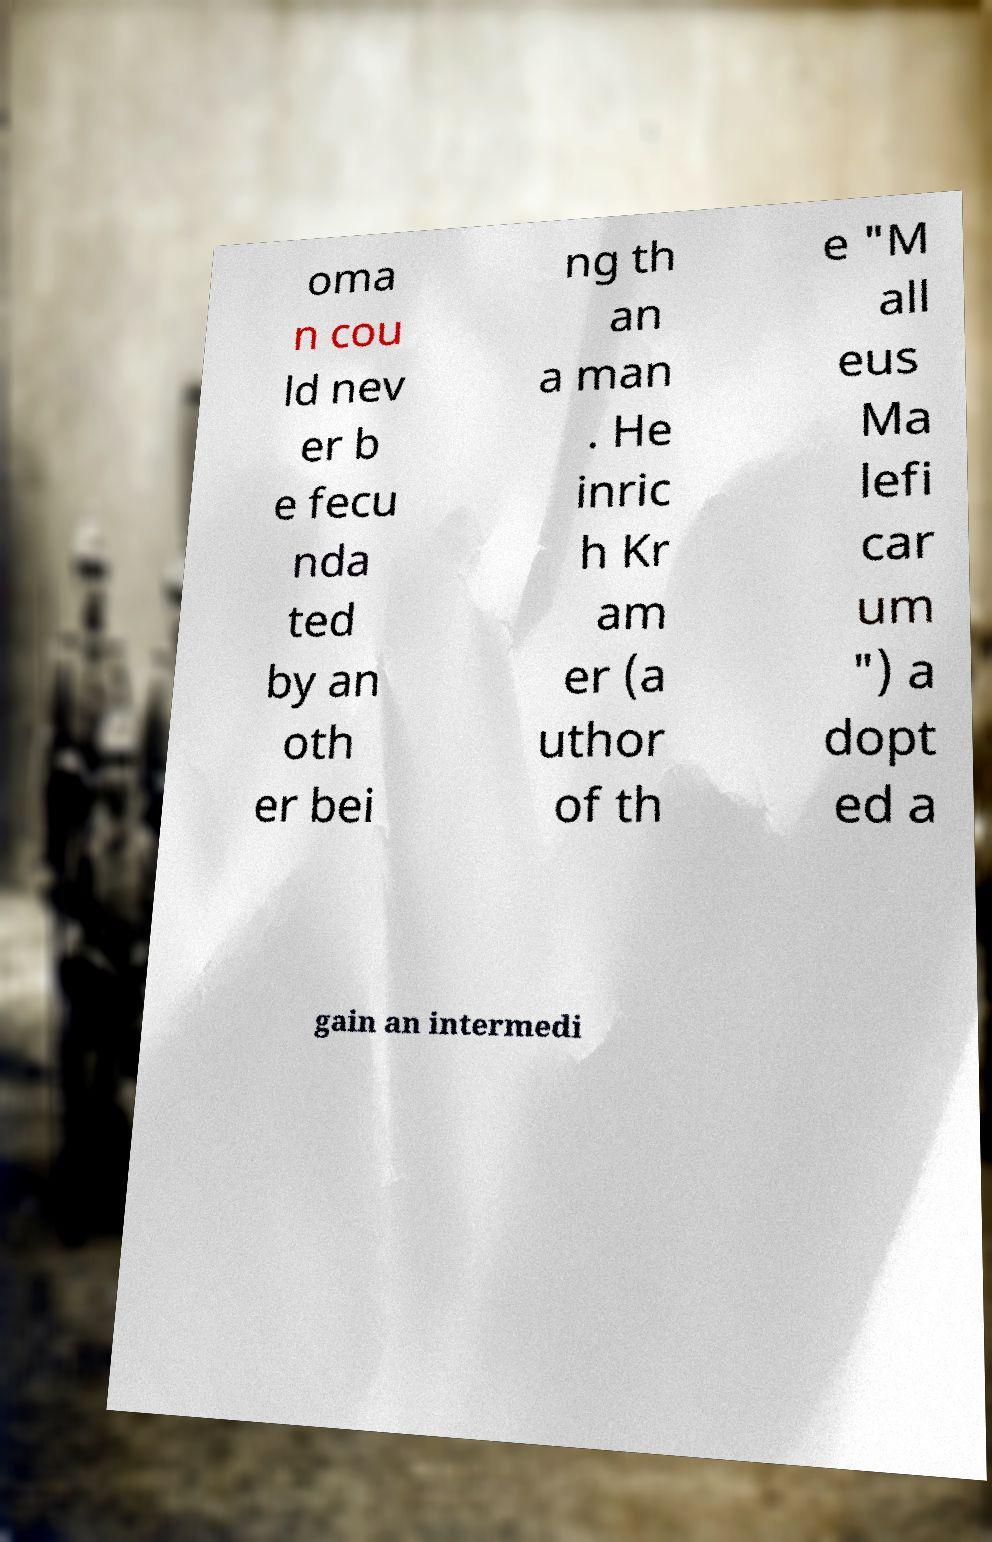For documentation purposes, I need the text within this image transcribed. Could you provide that? oma n cou ld nev er b e fecu nda ted by an oth er bei ng th an a man . He inric h Kr am er (a uthor of th e "M all eus Ma lefi car um ") a dopt ed a gain an intermedi 